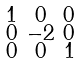<formula> <loc_0><loc_0><loc_500><loc_500>\begin{smallmatrix} 1 & 0 & 0 \\ 0 & - 2 & 0 \\ 0 & 0 & 1 \\ \end{smallmatrix}</formula> 